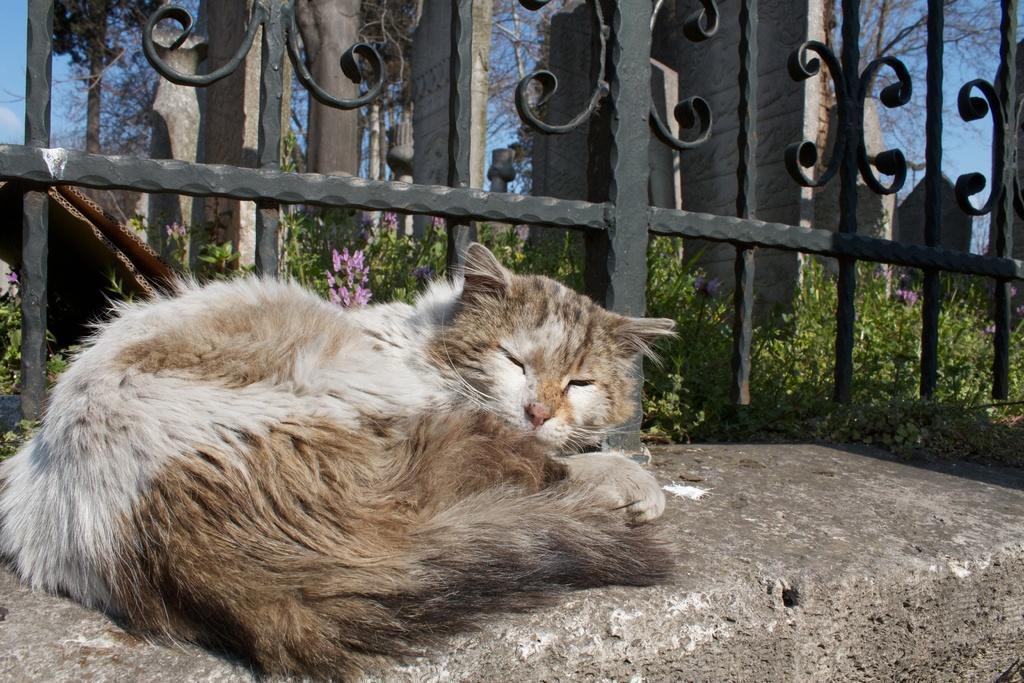How would you summarize this image in a sentence or two? In this picture we can see a cat on a stone, fence, plants with flowers, some objects, trees and in the background we can see the sky. 